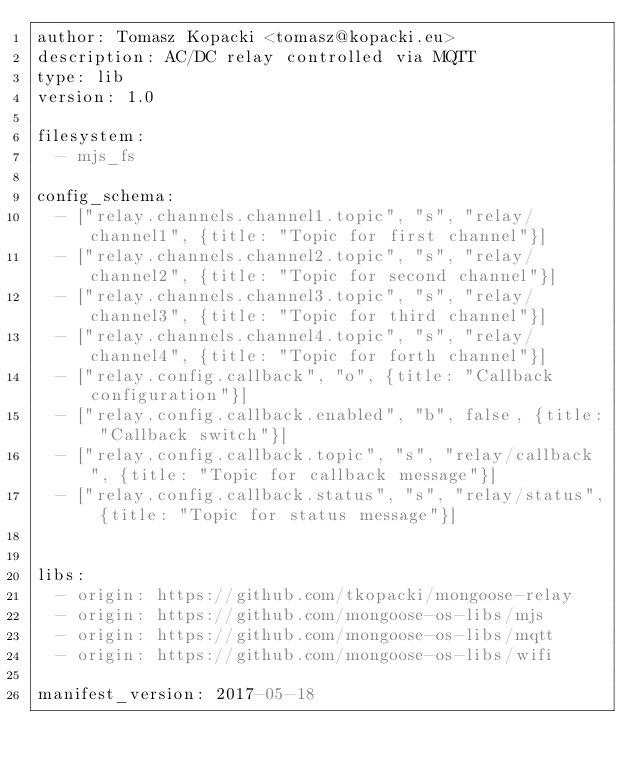Convert code to text. <code><loc_0><loc_0><loc_500><loc_500><_YAML_>author: Tomasz Kopacki <tomasz@kopacki.eu>
description: AC/DC relay controlled via MQTT
type: lib
version: 1.0

filesystem:
  - mjs_fs

config_schema:
  - ["relay.channels.channel1.topic", "s", "relay/channel1", {title: "Topic for first channel"}]
  - ["relay.channels.channel2.topic", "s", "relay/channel2", {title: "Topic for second channel"}]
  - ["relay.channels.channel3.topic", "s", "relay/channel3", {title: "Topic for third channel"}]
  - ["relay.channels.channel4.topic", "s", "relay/channel4", {title: "Topic for forth channel"}]
  - ["relay.config.callback", "o", {title: "Callback configuration"}]
  - ["relay.config.callback.enabled", "b", false, {title: "Callback switch"}]
  - ["relay.config.callback.topic", "s", "relay/callback", {title: "Topic for callback message"}]
  - ["relay.config.callback.status", "s", "relay/status", {title: "Topic for status message"}]


libs:
  - origin: https://github.com/tkopacki/mongoose-relay
  - origin: https://github.com/mongoose-os-libs/mjs
  - origin: https://github.com/mongoose-os-libs/mqtt
  - origin: https://github.com/mongoose-os-libs/wifi

manifest_version: 2017-05-18</code> 